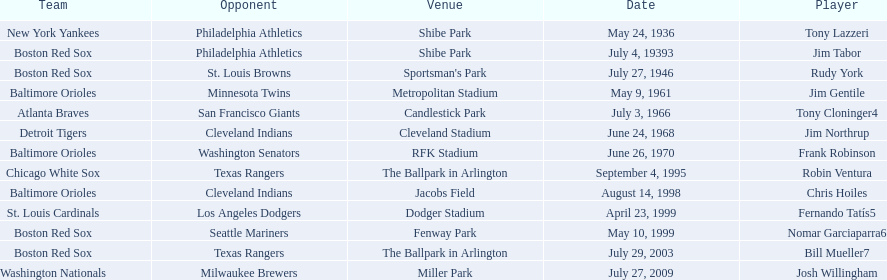Who are all the opponents? Philadelphia Athletics, Philadelphia Athletics, St. Louis Browns, Minnesota Twins, San Francisco Giants, Cleveland Indians, Washington Senators, Texas Rangers, Cleveland Indians, Los Angeles Dodgers, Seattle Mariners, Texas Rangers, Milwaukee Brewers. What teams played on july 27, 1946? Boston Red Sox, July 27, 1946, St. Louis Browns. Who was the opponent in this game? St. Louis Browns. 